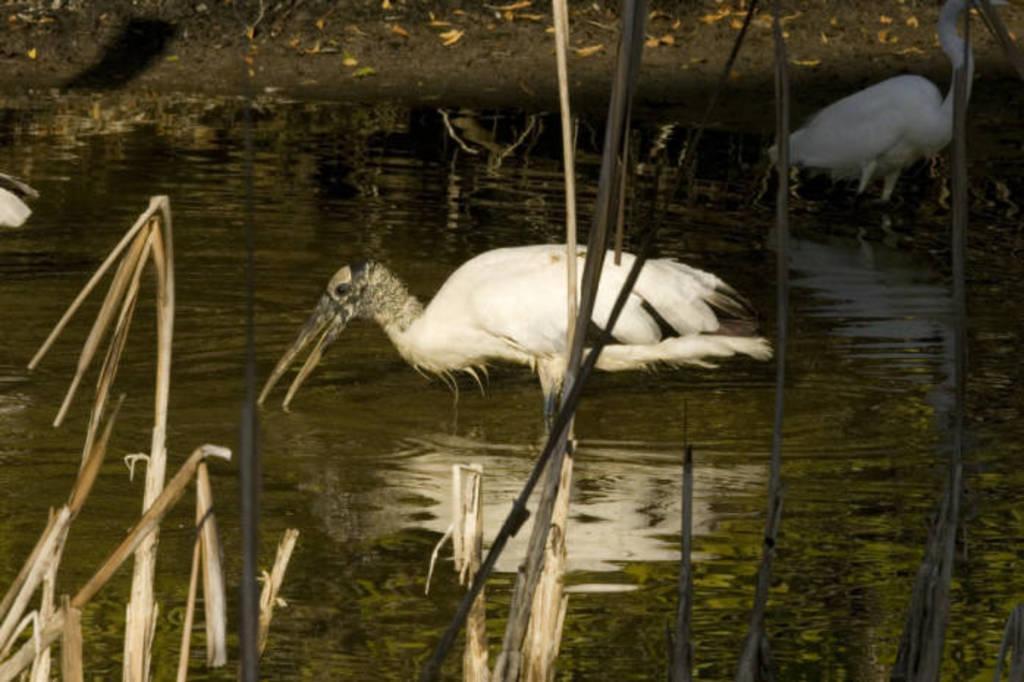Could you give a brief overview of what you see in this image? Here in this picture we can see cranes present in the water over a place and we can see small plants here and there. 